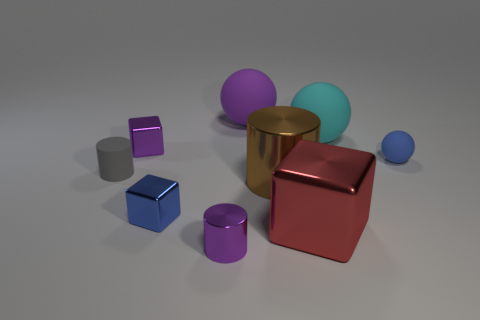Add 1 big metallic spheres. How many objects exist? 10 Subtract all cylinders. How many objects are left? 6 Subtract 2 cubes. How many cubes are left? 1 Subtract all blue balls. Subtract all purple cylinders. How many balls are left? 2 Subtract all yellow spheres. How many cyan cylinders are left? 0 Subtract all tiny yellow shiny cubes. Subtract all large objects. How many objects are left? 5 Add 4 large cyan objects. How many large cyan objects are left? 5 Add 7 large cyan objects. How many large cyan objects exist? 8 Subtract all purple spheres. How many spheres are left? 2 Subtract all purple metallic blocks. How many blocks are left? 2 